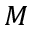<formula> <loc_0><loc_0><loc_500><loc_500>{ M }</formula> 